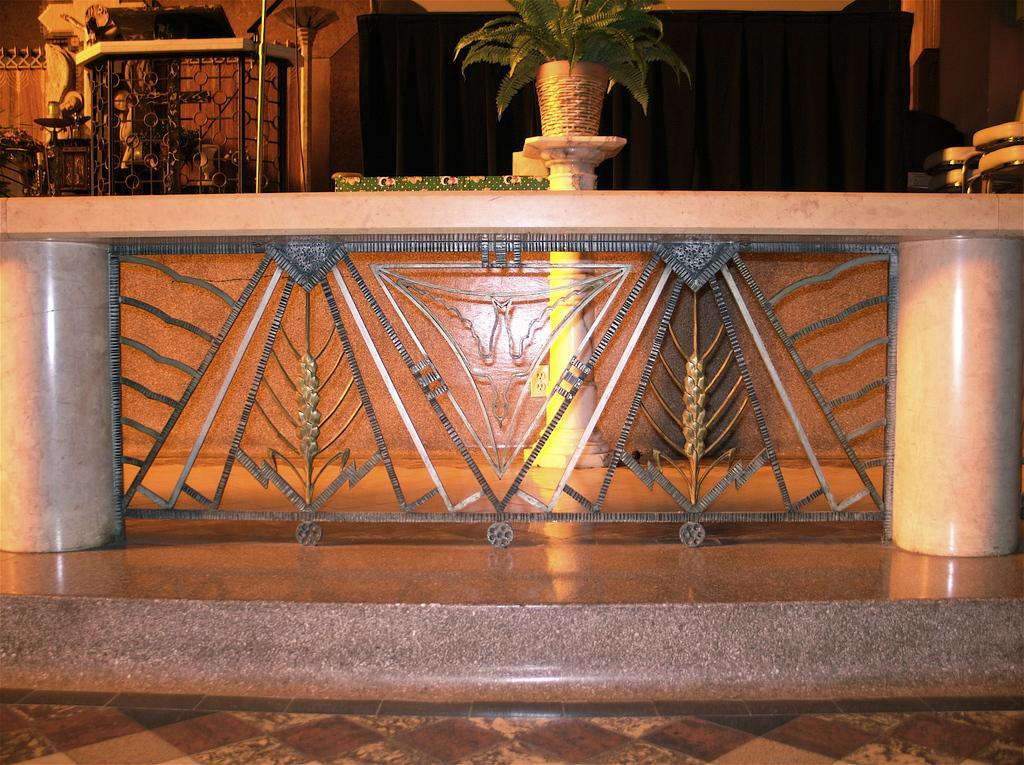Describe this image in one or two sentences. In this picture I can observe a desk in the middle of the picture. In the top of the picture I can observe a plant pot. In the background I can observe black color curtain. 